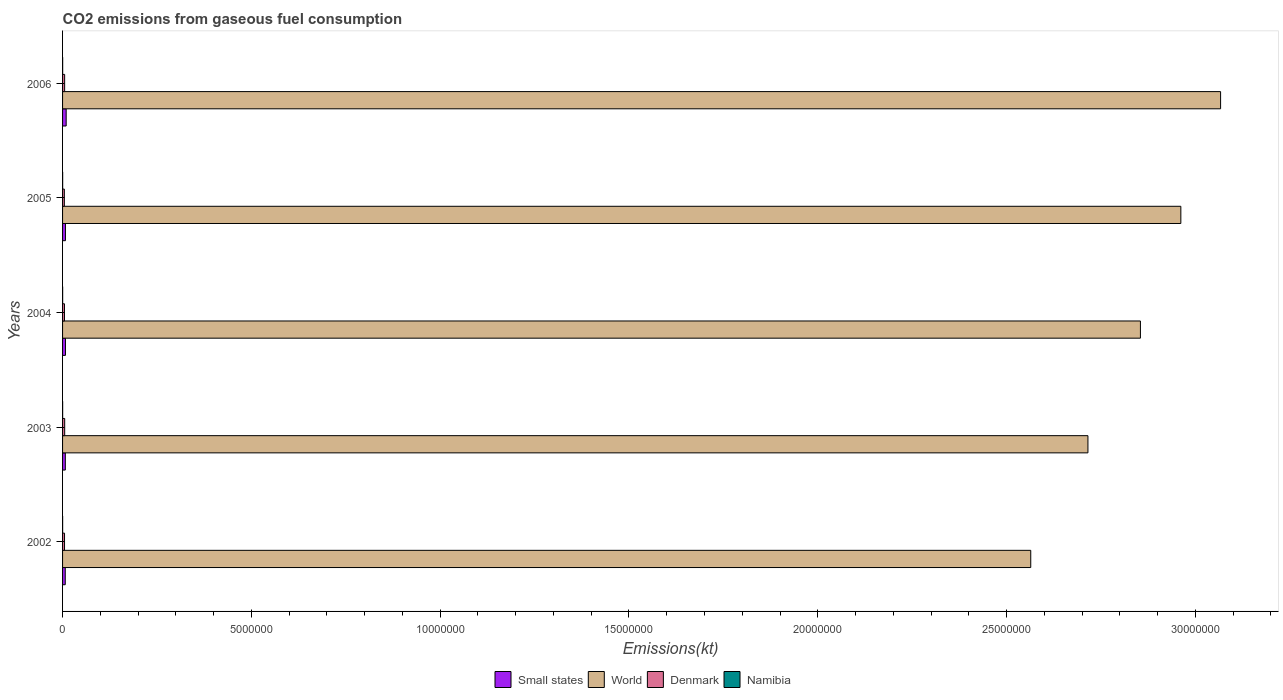How many groups of bars are there?
Provide a succinct answer. 5. Are the number of bars per tick equal to the number of legend labels?
Your answer should be very brief. Yes. Are the number of bars on each tick of the Y-axis equal?
Provide a short and direct response. Yes. How many bars are there on the 5th tick from the bottom?
Your answer should be very brief. 4. What is the label of the 4th group of bars from the top?
Provide a succinct answer. 2003. In how many cases, is the number of bars for a given year not equal to the number of legend labels?
Offer a very short reply. 0. What is the amount of CO2 emitted in Denmark in 2005?
Your answer should be very brief. 4.71e+04. Across all years, what is the maximum amount of CO2 emitted in Denmark?
Your answer should be compact. 5.60e+04. Across all years, what is the minimum amount of CO2 emitted in Namibia?
Provide a succinct answer. 1760.16. In which year was the amount of CO2 emitted in Small states maximum?
Make the answer very short. 2006. What is the total amount of CO2 emitted in World in the graph?
Offer a very short reply. 1.42e+08. What is the difference between the amount of CO2 emitted in Denmark in 2004 and that in 2006?
Your answer should be compact. -4385.73. What is the difference between the amount of CO2 emitted in Denmark in 2004 and the amount of CO2 emitted in World in 2006?
Provide a short and direct response. -3.06e+07. What is the average amount of CO2 emitted in World per year?
Your answer should be compact. 2.83e+07. In the year 2002, what is the difference between the amount of CO2 emitted in Namibia and amount of CO2 emitted in Small states?
Your answer should be very brief. -6.93e+04. In how many years, is the amount of CO2 emitted in Small states greater than 18000000 kt?
Offer a very short reply. 0. What is the ratio of the amount of CO2 emitted in Denmark in 2004 to that in 2005?
Provide a succinct answer. 1.07. What is the difference between the highest and the second highest amount of CO2 emitted in Namibia?
Provide a short and direct response. 18.34. What is the difference between the highest and the lowest amount of CO2 emitted in Namibia?
Offer a very short reply. 568.38. Is it the case that in every year, the sum of the amount of CO2 emitted in Denmark and amount of CO2 emitted in Namibia is greater than the sum of amount of CO2 emitted in Small states and amount of CO2 emitted in World?
Your answer should be very brief. No. What does the 3rd bar from the top in 2003 represents?
Provide a short and direct response. World. What does the 2nd bar from the bottom in 2006 represents?
Your response must be concise. World. Are all the bars in the graph horizontal?
Offer a terse response. Yes. How many years are there in the graph?
Keep it short and to the point. 5. What is the difference between two consecutive major ticks on the X-axis?
Make the answer very short. 5.00e+06. How many legend labels are there?
Your answer should be compact. 4. How are the legend labels stacked?
Keep it short and to the point. Horizontal. What is the title of the graph?
Provide a short and direct response. CO2 emissions from gaseous fuel consumption. What is the label or title of the X-axis?
Give a very brief answer. Emissions(kt). What is the label or title of the Y-axis?
Give a very brief answer. Years. What is the Emissions(kt) of Small states in 2002?
Your answer should be compact. 7.11e+04. What is the Emissions(kt) of World in 2002?
Offer a very short reply. 2.56e+07. What is the Emissions(kt) in Denmark in 2002?
Provide a short and direct response. 5.20e+04. What is the Emissions(kt) of Namibia in 2002?
Keep it short and to the point. 1760.16. What is the Emissions(kt) in Small states in 2003?
Ensure brevity in your answer.  7.31e+04. What is the Emissions(kt) of World in 2003?
Your answer should be compact. 2.72e+07. What is the Emissions(kt) in Denmark in 2003?
Offer a terse response. 5.60e+04. What is the Emissions(kt) of Namibia in 2003?
Make the answer very short. 1873.84. What is the Emissions(kt) of Small states in 2004?
Offer a very short reply. 7.69e+04. What is the Emissions(kt) in World in 2004?
Make the answer very short. 2.85e+07. What is the Emissions(kt) of Denmark in 2004?
Give a very brief answer. 5.06e+04. What is the Emissions(kt) in Namibia in 2004?
Give a very brief answer. 1961.85. What is the Emissions(kt) of Small states in 2005?
Ensure brevity in your answer.  7.63e+04. What is the Emissions(kt) in World in 2005?
Provide a short and direct response. 2.96e+07. What is the Emissions(kt) of Denmark in 2005?
Provide a succinct answer. 4.71e+04. What is the Emissions(kt) of Namibia in 2005?
Ensure brevity in your answer.  2310.21. What is the Emissions(kt) in Small states in 2006?
Provide a short and direct response. 9.55e+04. What is the Emissions(kt) of World in 2006?
Offer a terse response. 3.07e+07. What is the Emissions(kt) of Denmark in 2006?
Your response must be concise. 5.50e+04. What is the Emissions(kt) of Namibia in 2006?
Your answer should be very brief. 2328.55. Across all years, what is the maximum Emissions(kt) of Small states?
Provide a short and direct response. 9.55e+04. Across all years, what is the maximum Emissions(kt) in World?
Offer a very short reply. 3.07e+07. Across all years, what is the maximum Emissions(kt) of Denmark?
Offer a very short reply. 5.60e+04. Across all years, what is the maximum Emissions(kt) of Namibia?
Your answer should be very brief. 2328.55. Across all years, what is the minimum Emissions(kt) in Small states?
Give a very brief answer. 7.11e+04. Across all years, what is the minimum Emissions(kt) in World?
Provide a succinct answer. 2.56e+07. Across all years, what is the minimum Emissions(kt) in Denmark?
Your answer should be compact. 4.71e+04. Across all years, what is the minimum Emissions(kt) of Namibia?
Your response must be concise. 1760.16. What is the total Emissions(kt) of Small states in the graph?
Make the answer very short. 3.93e+05. What is the total Emissions(kt) of World in the graph?
Make the answer very short. 1.42e+08. What is the total Emissions(kt) of Denmark in the graph?
Offer a very short reply. 2.61e+05. What is the total Emissions(kt) of Namibia in the graph?
Keep it short and to the point. 1.02e+04. What is the difference between the Emissions(kt) in Small states in 2002 and that in 2003?
Make the answer very short. -1987.15. What is the difference between the Emissions(kt) of World in 2002 and that in 2003?
Your answer should be very brief. -1.51e+06. What is the difference between the Emissions(kt) in Denmark in 2002 and that in 2003?
Provide a succinct answer. -3949.36. What is the difference between the Emissions(kt) of Namibia in 2002 and that in 2003?
Your response must be concise. -113.68. What is the difference between the Emissions(kt) of Small states in 2002 and that in 2004?
Offer a terse response. -5869.22. What is the difference between the Emissions(kt) of World in 2002 and that in 2004?
Provide a short and direct response. -2.90e+06. What is the difference between the Emissions(kt) of Denmark in 2002 and that in 2004?
Ensure brevity in your answer.  1448.46. What is the difference between the Emissions(kt) of Namibia in 2002 and that in 2004?
Keep it short and to the point. -201.69. What is the difference between the Emissions(kt) of Small states in 2002 and that in 2005?
Make the answer very short. -5211.96. What is the difference between the Emissions(kt) in World in 2002 and that in 2005?
Provide a succinct answer. -3.98e+06. What is the difference between the Emissions(kt) in Denmark in 2002 and that in 2005?
Ensure brevity in your answer.  4954.12. What is the difference between the Emissions(kt) of Namibia in 2002 and that in 2005?
Make the answer very short. -550.05. What is the difference between the Emissions(kt) in Small states in 2002 and that in 2006?
Make the answer very short. -2.44e+04. What is the difference between the Emissions(kt) in World in 2002 and that in 2006?
Ensure brevity in your answer.  -5.03e+06. What is the difference between the Emissions(kt) of Denmark in 2002 and that in 2006?
Give a very brief answer. -2937.27. What is the difference between the Emissions(kt) of Namibia in 2002 and that in 2006?
Provide a short and direct response. -568.38. What is the difference between the Emissions(kt) in Small states in 2003 and that in 2004?
Your answer should be very brief. -3882.06. What is the difference between the Emissions(kt) in World in 2003 and that in 2004?
Your answer should be compact. -1.39e+06. What is the difference between the Emissions(kt) in Denmark in 2003 and that in 2004?
Offer a terse response. 5397.82. What is the difference between the Emissions(kt) of Namibia in 2003 and that in 2004?
Offer a very short reply. -88.01. What is the difference between the Emissions(kt) in Small states in 2003 and that in 2005?
Keep it short and to the point. -3224.8. What is the difference between the Emissions(kt) in World in 2003 and that in 2005?
Offer a very short reply. -2.46e+06. What is the difference between the Emissions(kt) of Denmark in 2003 and that in 2005?
Keep it short and to the point. 8903.48. What is the difference between the Emissions(kt) in Namibia in 2003 and that in 2005?
Offer a terse response. -436.37. What is the difference between the Emissions(kt) in Small states in 2003 and that in 2006?
Give a very brief answer. -2.24e+04. What is the difference between the Emissions(kt) in World in 2003 and that in 2006?
Your answer should be very brief. -3.51e+06. What is the difference between the Emissions(kt) of Denmark in 2003 and that in 2006?
Your answer should be compact. 1012.09. What is the difference between the Emissions(kt) in Namibia in 2003 and that in 2006?
Keep it short and to the point. -454.71. What is the difference between the Emissions(kt) in Small states in 2004 and that in 2005?
Your answer should be very brief. 657.26. What is the difference between the Emissions(kt) of World in 2004 and that in 2005?
Provide a succinct answer. -1.07e+06. What is the difference between the Emissions(kt) in Denmark in 2004 and that in 2005?
Make the answer very short. 3505.65. What is the difference between the Emissions(kt) of Namibia in 2004 and that in 2005?
Your answer should be compact. -348.37. What is the difference between the Emissions(kt) of Small states in 2004 and that in 2006?
Your answer should be very brief. -1.85e+04. What is the difference between the Emissions(kt) in World in 2004 and that in 2006?
Provide a short and direct response. -2.12e+06. What is the difference between the Emissions(kt) in Denmark in 2004 and that in 2006?
Ensure brevity in your answer.  -4385.73. What is the difference between the Emissions(kt) of Namibia in 2004 and that in 2006?
Your response must be concise. -366.7. What is the difference between the Emissions(kt) in Small states in 2005 and that in 2006?
Keep it short and to the point. -1.92e+04. What is the difference between the Emissions(kt) of World in 2005 and that in 2006?
Offer a terse response. -1.05e+06. What is the difference between the Emissions(kt) in Denmark in 2005 and that in 2006?
Provide a succinct answer. -7891.38. What is the difference between the Emissions(kt) in Namibia in 2005 and that in 2006?
Make the answer very short. -18.34. What is the difference between the Emissions(kt) in Small states in 2002 and the Emissions(kt) in World in 2003?
Make the answer very short. -2.71e+07. What is the difference between the Emissions(kt) in Small states in 2002 and the Emissions(kt) in Denmark in 2003?
Keep it short and to the point. 1.51e+04. What is the difference between the Emissions(kt) of Small states in 2002 and the Emissions(kt) of Namibia in 2003?
Give a very brief answer. 6.92e+04. What is the difference between the Emissions(kt) in World in 2002 and the Emissions(kt) in Denmark in 2003?
Give a very brief answer. 2.56e+07. What is the difference between the Emissions(kt) in World in 2002 and the Emissions(kt) in Namibia in 2003?
Make the answer very short. 2.56e+07. What is the difference between the Emissions(kt) in Denmark in 2002 and the Emissions(kt) in Namibia in 2003?
Provide a succinct answer. 5.02e+04. What is the difference between the Emissions(kt) of Small states in 2002 and the Emissions(kt) of World in 2004?
Give a very brief answer. -2.85e+07. What is the difference between the Emissions(kt) in Small states in 2002 and the Emissions(kt) in Denmark in 2004?
Your answer should be compact. 2.05e+04. What is the difference between the Emissions(kt) in Small states in 2002 and the Emissions(kt) in Namibia in 2004?
Provide a short and direct response. 6.91e+04. What is the difference between the Emissions(kt) in World in 2002 and the Emissions(kt) in Denmark in 2004?
Your response must be concise. 2.56e+07. What is the difference between the Emissions(kt) of World in 2002 and the Emissions(kt) of Namibia in 2004?
Make the answer very short. 2.56e+07. What is the difference between the Emissions(kt) in Denmark in 2002 and the Emissions(kt) in Namibia in 2004?
Make the answer very short. 5.01e+04. What is the difference between the Emissions(kt) of Small states in 2002 and the Emissions(kt) of World in 2005?
Your response must be concise. -2.95e+07. What is the difference between the Emissions(kt) in Small states in 2002 and the Emissions(kt) in Denmark in 2005?
Your answer should be very brief. 2.40e+04. What is the difference between the Emissions(kt) of Small states in 2002 and the Emissions(kt) of Namibia in 2005?
Your response must be concise. 6.88e+04. What is the difference between the Emissions(kt) of World in 2002 and the Emissions(kt) of Denmark in 2005?
Offer a terse response. 2.56e+07. What is the difference between the Emissions(kt) in World in 2002 and the Emissions(kt) in Namibia in 2005?
Your answer should be very brief. 2.56e+07. What is the difference between the Emissions(kt) of Denmark in 2002 and the Emissions(kt) of Namibia in 2005?
Keep it short and to the point. 4.97e+04. What is the difference between the Emissions(kt) in Small states in 2002 and the Emissions(kt) in World in 2006?
Offer a terse response. -3.06e+07. What is the difference between the Emissions(kt) in Small states in 2002 and the Emissions(kt) in Denmark in 2006?
Offer a terse response. 1.61e+04. What is the difference between the Emissions(kt) of Small states in 2002 and the Emissions(kt) of Namibia in 2006?
Make the answer very short. 6.87e+04. What is the difference between the Emissions(kt) in World in 2002 and the Emissions(kt) in Denmark in 2006?
Your response must be concise. 2.56e+07. What is the difference between the Emissions(kt) of World in 2002 and the Emissions(kt) of Namibia in 2006?
Your answer should be compact. 2.56e+07. What is the difference between the Emissions(kt) in Denmark in 2002 and the Emissions(kt) in Namibia in 2006?
Make the answer very short. 4.97e+04. What is the difference between the Emissions(kt) in Small states in 2003 and the Emissions(kt) in World in 2004?
Provide a short and direct response. -2.85e+07. What is the difference between the Emissions(kt) in Small states in 2003 and the Emissions(kt) in Denmark in 2004?
Offer a very short reply. 2.25e+04. What is the difference between the Emissions(kt) in Small states in 2003 and the Emissions(kt) in Namibia in 2004?
Offer a terse response. 7.11e+04. What is the difference between the Emissions(kt) of World in 2003 and the Emissions(kt) of Denmark in 2004?
Make the answer very short. 2.71e+07. What is the difference between the Emissions(kt) in World in 2003 and the Emissions(kt) in Namibia in 2004?
Give a very brief answer. 2.72e+07. What is the difference between the Emissions(kt) of Denmark in 2003 and the Emissions(kt) of Namibia in 2004?
Offer a very short reply. 5.40e+04. What is the difference between the Emissions(kt) in Small states in 2003 and the Emissions(kt) in World in 2005?
Keep it short and to the point. -2.95e+07. What is the difference between the Emissions(kt) in Small states in 2003 and the Emissions(kt) in Denmark in 2005?
Make the answer very short. 2.60e+04. What is the difference between the Emissions(kt) in Small states in 2003 and the Emissions(kt) in Namibia in 2005?
Your response must be concise. 7.07e+04. What is the difference between the Emissions(kt) in World in 2003 and the Emissions(kt) in Denmark in 2005?
Offer a very short reply. 2.71e+07. What is the difference between the Emissions(kt) in World in 2003 and the Emissions(kt) in Namibia in 2005?
Your answer should be very brief. 2.72e+07. What is the difference between the Emissions(kt) of Denmark in 2003 and the Emissions(kt) of Namibia in 2005?
Your answer should be very brief. 5.37e+04. What is the difference between the Emissions(kt) in Small states in 2003 and the Emissions(kt) in World in 2006?
Provide a short and direct response. -3.06e+07. What is the difference between the Emissions(kt) of Small states in 2003 and the Emissions(kt) of Denmark in 2006?
Ensure brevity in your answer.  1.81e+04. What is the difference between the Emissions(kt) in Small states in 2003 and the Emissions(kt) in Namibia in 2006?
Your answer should be compact. 7.07e+04. What is the difference between the Emissions(kt) in World in 2003 and the Emissions(kt) in Denmark in 2006?
Keep it short and to the point. 2.71e+07. What is the difference between the Emissions(kt) in World in 2003 and the Emissions(kt) in Namibia in 2006?
Your response must be concise. 2.72e+07. What is the difference between the Emissions(kt) of Denmark in 2003 and the Emissions(kt) of Namibia in 2006?
Make the answer very short. 5.37e+04. What is the difference between the Emissions(kt) of Small states in 2004 and the Emissions(kt) of World in 2005?
Ensure brevity in your answer.  -2.95e+07. What is the difference between the Emissions(kt) of Small states in 2004 and the Emissions(kt) of Denmark in 2005?
Offer a very short reply. 2.98e+04. What is the difference between the Emissions(kt) in Small states in 2004 and the Emissions(kt) in Namibia in 2005?
Ensure brevity in your answer.  7.46e+04. What is the difference between the Emissions(kt) in World in 2004 and the Emissions(kt) in Denmark in 2005?
Give a very brief answer. 2.85e+07. What is the difference between the Emissions(kt) in World in 2004 and the Emissions(kt) in Namibia in 2005?
Give a very brief answer. 2.85e+07. What is the difference between the Emissions(kt) of Denmark in 2004 and the Emissions(kt) of Namibia in 2005?
Offer a very short reply. 4.83e+04. What is the difference between the Emissions(kt) in Small states in 2004 and the Emissions(kt) in World in 2006?
Offer a very short reply. -3.06e+07. What is the difference between the Emissions(kt) in Small states in 2004 and the Emissions(kt) in Denmark in 2006?
Your answer should be very brief. 2.20e+04. What is the difference between the Emissions(kt) of Small states in 2004 and the Emissions(kt) of Namibia in 2006?
Provide a succinct answer. 7.46e+04. What is the difference between the Emissions(kt) of World in 2004 and the Emissions(kt) of Denmark in 2006?
Ensure brevity in your answer.  2.85e+07. What is the difference between the Emissions(kt) of World in 2004 and the Emissions(kt) of Namibia in 2006?
Your answer should be very brief. 2.85e+07. What is the difference between the Emissions(kt) of Denmark in 2004 and the Emissions(kt) of Namibia in 2006?
Your answer should be compact. 4.83e+04. What is the difference between the Emissions(kt) of Small states in 2005 and the Emissions(kt) of World in 2006?
Keep it short and to the point. -3.06e+07. What is the difference between the Emissions(kt) of Small states in 2005 and the Emissions(kt) of Denmark in 2006?
Keep it short and to the point. 2.13e+04. What is the difference between the Emissions(kt) in Small states in 2005 and the Emissions(kt) in Namibia in 2006?
Give a very brief answer. 7.40e+04. What is the difference between the Emissions(kt) in World in 2005 and the Emissions(kt) in Denmark in 2006?
Give a very brief answer. 2.96e+07. What is the difference between the Emissions(kt) in World in 2005 and the Emissions(kt) in Namibia in 2006?
Give a very brief answer. 2.96e+07. What is the difference between the Emissions(kt) in Denmark in 2005 and the Emissions(kt) in Namibia in 2006?
Your answer should be very brief. 4.48e+04. What is the average Emissions(kt) of Small states per year?
Your response must be concise. 7.86e+04. What is the average Emissions(kt) in World per year?
Offer a very short reply. 2.83e+07. What is the average Emissions(kt) of Denmark per year?
Provide a succinct answer. 5.21e+04. What is the average Emissions(kt) in Namibia per year?
Offer a very short reply. 2046.92. In the year 2002, what is the difference between the Emissions(kt) of Small states and Emissions(kt) of World?
Provide a succinct answer. -2.56e+07. In the year 2002, what is the difference between the Emissions(kt) of Small states and Emissions(kt) of Denmark?
Your answer should be compact. 1.90e+04. In the year 2002, what is the difference between the Emissions(kt) of Small states and Emissions(kt) of Namibia?
Offer a very short reply. 6.93e+04. In the year 2002, what is the difference between the Emissions(kt) in World and Emissions(kt) in Denmark?
Your response must be concise. 2.56e+07. In the year 2002, what is the difference between the Emissions(kt) in World and Emissions(kt) in Namibia?
Provide a short and direct response. 2.56e+07. In the year 2002, what is the difference between the Emissions(kt) in Denmark and Emissions(kt) in Namibia?
Provide a short and direct response. 5.03e+04. In the year 2003, what is the difference between the Emissions(kt) of Small states and Emissions(kt) of World?
Offer a terse response. -2.71e+07. In the year 2003, what is the difference between the Emissions(kt) in Small states and Emissions(kt) in Denmark?
Provide a succinct answer. 1.71e+04. In the year 2003, what is the difference between the Emissions(kt) of Small states and Emissions(kt) of Namibia?
Ensure brevity in your answer.  7.12e+04. In the year 2003, what is the difference between the Emissions(kt) in World and Emissions(kt) in Denmark?
Provide a short and direct response. 2.71e+07. In the year 2003, what is the difference between the Emissions(kt) in World and Emissions(kt) in Namibia?
Your answer should be very brief. 2.72e+07. In the year 2003, what is the difference between the Emissions(kt) of Denmark and Emissions(kt) of Namibia?
Keep it short and to the point. 5.41e+04. In the year 2004, what is the difference between the Emissions(kt) of Small states and Emissions(kt) of World?
Your response must be concise. -2.85e+07. In the year 2004, what is the difference between the Emissions(kt) in Small states and Emissions(kt) in Denmark?
Make the answer very short. 2.63e+04. In the year 2004, what is the difference between the Emissions(kt) of Small states and Emissions(kt) of Namibia?
Provide a short and direct response. 7.50e+04. In the year 2004, what is the difference between the Emissions(kt) of World and Emissions(kt) of Denmark?
Ensure brevity in your answer.  2.85e+07. In the year 2004, what is the difference between the Emissions(kt) in World and Emissions(kt) in Namibia?
Make the answer very short. 2.85e+07. In the year 2004, what is the difference between the Emissions(kt) of Denmark and Emissions(kt) of Namibia?
Your answer should be very brief. 4.86e+04. In the year 2005, what is the difference between the Emissions(kt) in Small states and Emissions(kt) in World?
Offer a terse response. -2.95e+07. In the year 2005, what is the difference between the Emissions(kt) of Small states and Emissions(kt) of Denmark?
Your response must be concise. 2.92e+04. In the year 2005, what is the difference between the Emissions(kt) of Small states and Emissions(kt) of Namibia?
Make the answer very short. 7.40e+04. In the year 2005, what is the difference between the Emissions(kt) in World and Emissions(kt) in Denmark?
Provide a succinct answer. 2.96e+07. In the year 2005, what is the difference between the Emissions(kt) of World and Emissions(kt) of Namibia?
Keep it short and to the point. 2.96e+07. In the year 2005, what is the difference between the Emissions(kt) in Denmark and Emissions(kt) in Namibia?
Offer a very short reply. 4.48e+04. In the year 2006, what is the difference between the Emissions(kt) in Small states and Emissions(kt) in World?
Your answer should be very brief. -3.06e+07. In the year 2006, what is the difference between the Emissions(kt) of Small states and Emissions(kt) of Denmark?
Your answer should be compact. 4.05e+04. In the year 2006, what is the difference between the Emissions(kt) in Small states and Emissions(kt) in Namibia?
Provide a short and direct response. 9.32e+04. In the year 2006, what is the difference between the Emissions(kt) in World and Emissions(kt) in Denmark?
Make the answer very short. 3.06e+07. In the year 2006, what is the difference between the Emissions(kt) in World and Emissions(kt) in Namibia?
Offer a terse response. 3.07e+07. In the year 2006, what is the difference between the Emissions(kt) in Denmark and Emissions(kt) in Namibia?
Keep it short and to the point. 5.27e+04. What is the ratio of the Emissions(kt) in Small states in 2002 to that in 2003?
Your answer should be very brief. 0.97. What is the ratio of the Emissions(kt) of World in 2002 to that in 2003?
Offer a very short reply. 0.94. What is the ratio of the Emissions(kt) in Denmark in 2002 to that in 2003?
Ensure brevity in your answer.  0.93. What is the ratio of the Emissions(kt) in Namibia in 2002 to that in 2003?
Make the answer very short. 0.94. What is the ratio of the Emissions(kt) of Small states in 2002 to that in 2004?
Your answer should be very brief. 0.92. What is the ratio of the Emissions(kt) in World in 2002 to that in 2004?
Provide a succinct answer. 0.9. What is the ratio of the Emissions(kt) in Denmark in 2002 to that in 2004?
Your answer should be compact. 1.03. What is the ratio of the Emissions(kt) of Namibia in 2002 to that in 2004?
Provide a short and direct response. 0.9. What is the ratio of the Emissions(kt) of Small states in 2002 to that in 2005?
Provide a short and direct response. 0.93. What is the ratio of the Emissions(kt) of World in 2002 to that in 2005?
Your answer should be compact. 0.87. What is the ratio of the Emissions(kt) of Denmark in 2002 to that in 2005?
Keep it short and to the point. 1.11. What is the ratio of the Emissions(kt) in Namibia in 2002 to that in 2005?
Ensure brevity in your answer.  0.76. What is the ratio of the Emissions(kt) in Small states in 2002 to that in 2006?
Keep it short and to the point. 0.74. What is the ratio of the Emissions(kt) of World in 2002 to that in 2006?
Provide a short and direct response. 0.84. What is the ratio of the Emissions(kt) in Denmark in 2002 to that in 2006?
Make the answer very short. 0.95. What is the ratio of the Emissions(kt) in Namibia in 2002 to that in 2006?
Provide a succinct answer. 0.76. What is the ratio of the Emissions(kt) in Small states in 2003 to that in 2004?
Your response must be concise. 0.95. What is the ratio of the Emissions(kt) in World in 2003 to that in 2004?
Make the answer very short. 0.95. What is the ratio of the Emissions(kt) of Denmark in 2003 to that in 2004?
Offer a very short reply. 1.11. What is the ratio of the Emissions(kt) in Namibia in 2003 to that in 2004?
Offer a very short reply. 0.96. What is the ratio of the Emissions(kt) in Small states in 2003 to that in 2005?
Offer a very short reply. 0.96. What is the ratio of the Emissions(kt) in World in 2003 to that in 2005?
Your response must be concise. 0.92. What is the ratio of the Emissions(kt) in Denmark in 2003 to that in 2005?
Your response must be concise. 1.19. What is the ratio of the Emissions(kt) of Namibia in 2003 to that in 2005?
Give a very brief answer. 0.81. What is the ratio of the Emissions(kt) in Small states in 2003 to that in 2006?
Offer a terse response. 0.77. What is the ratio of the Emissions(kt) in World in 2003 to that in 2006?
Offer a very short reply. 0.89. What is the ratio of the Emissions(kt) of Denmark in 2003 to that in 2006?
Ensure brevity in your answer.  1.02. What is the ratio of the Emissions(kt) of Namibia in 2003 to that in 2006?
Make the answer very short. 0.8. What is the ratio of the Emissions(kt) of Small states in 2004 to that in 2005?
Your answer should be very brief. 1.01. What is the ratio of the Emissions(kt) of World in 2004 to that in 2005?
Give a very brief answer. 0.96. What is the ratio of the Emissions(kt) in Denmark in 2004 to that in 2005?
Your answer should be compact. 1.07. What is the ratio of the Emissions(kt) of Namibia in 2004 to that in 2005?
Your answer should be compact. 0.85. What is the ratio of the Emissions(kt) of Small states in 2004 to that in 2006?
Your answer should be compact. 0.81. What is the ratio of the Emissions(kt) of World in 2004 to that in 2006?
Offer a terse response. 0.93. What is the ratio of the Emissions(kt) in Denmark in 2004 to that in 2006?
Offer a very short reply. 0.92. What is the ratio of the Emissions(kt) of Namibia in 2004 to that in 2006?
Ensure brevity in your answer.  0.84. What is the ratio of the Emissions(kt) of Small states in 2005 to that in 2006?
Make the answer very short. 0.8. What is the ratio of the Emissions(kt) in World in 2005 to that in 2006?
Keep it short and to the point. 0.97. What is the ratio of the Emissions(kt) in Denmark in 2005 to that in 2006?
Provide a short and direct response. 0.86. What is the difference between the highest and the second highest Emissions(kt) in Small states?
Your answer should be compact. 1.85e+04. What is the difference between the highest and the second highest Emissions(kt) in World?
Your response must be concise. 1.05e+06. What is the difference between the highest and the second highest Emissions(kt) of Denmark?
Make the answer very short. 1012.09. What is the difference between the highest and the second highest Emissions(kt) of Namibia?
Provide a succinct answer. 18.34. What is the difference between the highest and the lowest Emissions(kt) in Small states?
Give a very brief answer. 2.44e+04. What is the difference between the highest and the lowest Emissions(kt) in World?
Give a very brief answer. 5.03e+06. What is the difference between the highest and the lowest Emissions(kt) in Denmark?
Keep it short and to the point. 8903.48. What is the difference between the highest and the lowest Emissions(kt) in Namibia?
Keep it short and to the point. 568.38. 